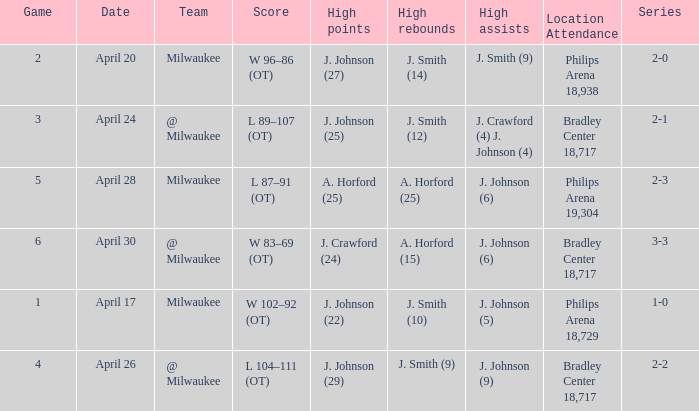What were the amount of rebounds in game 2? J. Smith (14). 